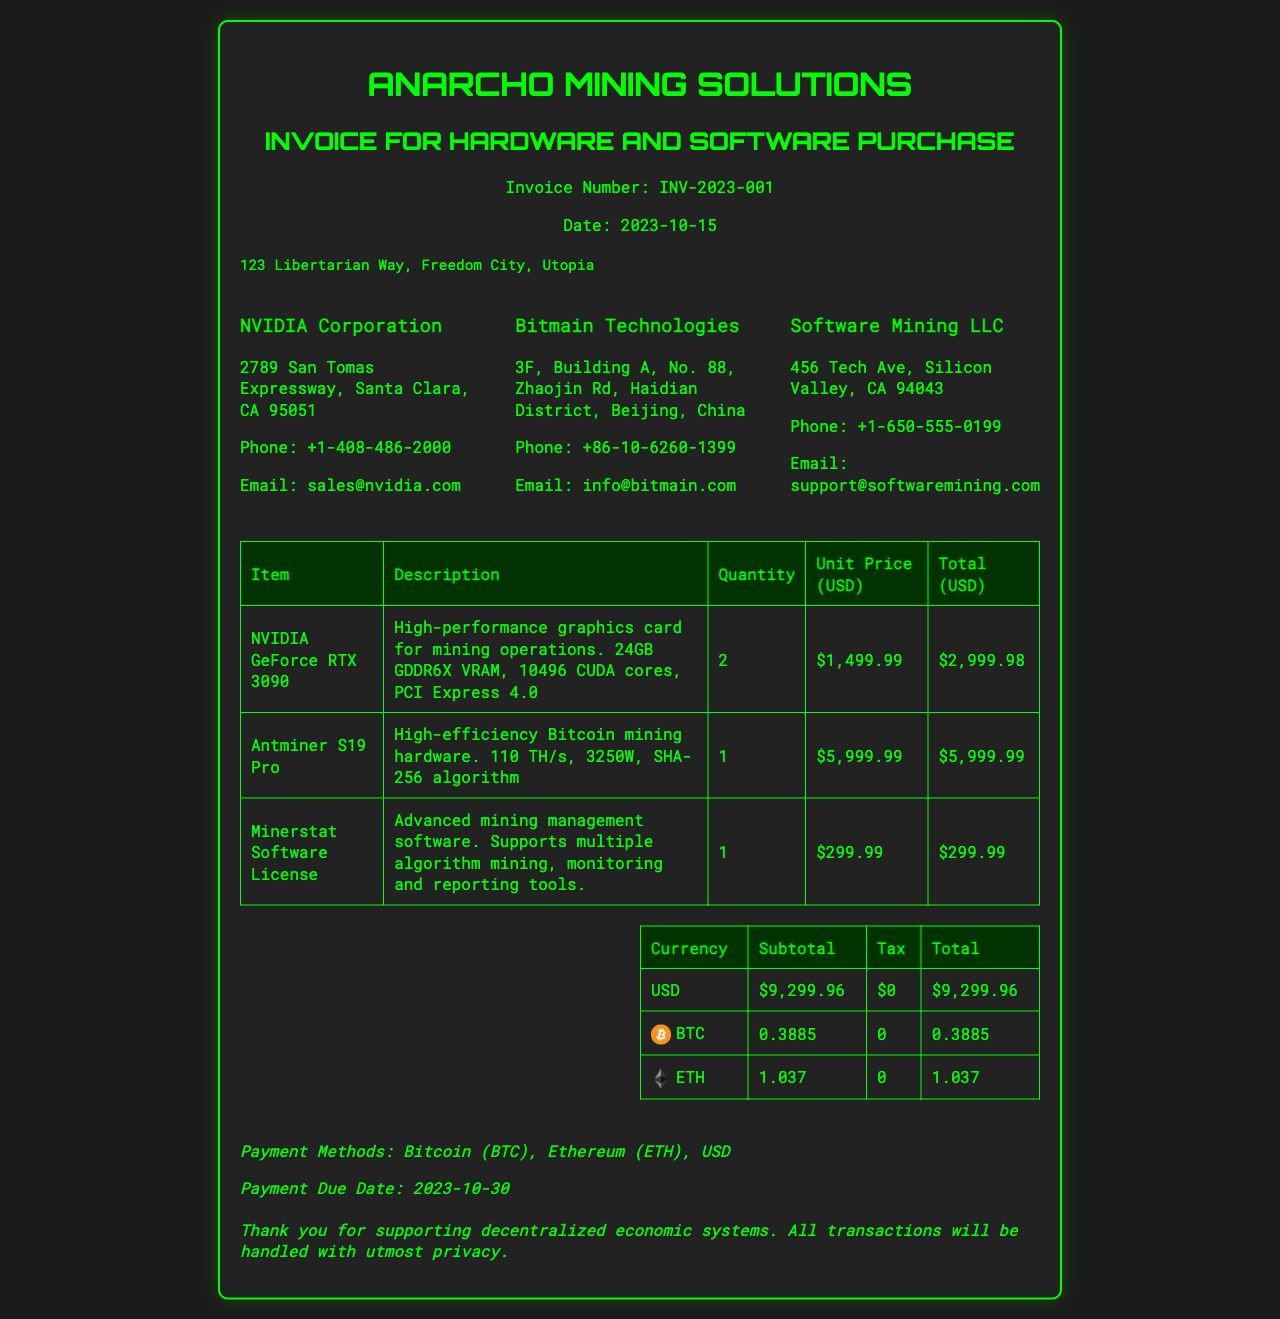what is the invoice number? The invoice number is uniquely assigned to this document for identification, which is INV-2023-001.
Answer: INV-2023-001 what is the date of the invoice? The date when this invoice was issued is important for payment timing and record keeping, which is 2023-10-15.
Answer: 2023-10-15 how many NVIDIA GeForce RTX 3090 graphics cards were purchased? The quantity specified for the NVIDIA GeForce RTX 3090 indicates how many were bought, which is 2.
Answer: 2 what is the total amount due in USD? The total amount due is the final cost of all items listed in the invoice, which sums up to $9,299.96.
Answer: $9,299.96 who is the vendor for the Antminer S19 Pro? The vendor information elaborates on the source of this product, which is Bitmain Technologies.
Answer: Bitmain Technologies what is the unit price of the Minerstat Software License? The unit price reflects the cost of a single item and is noted as $299.99.
Answer: $299.99 what are the payment methods accepted? Payment methods listed provide options for settling the invoice, which include Bitcoin, Ethereum, and USD.
Answer: Bitcoin, Ethereum, USD how much is the total in Bitcoin? Total in Bitcoin represents the equivalent amount due when choosing this payment method, which is 0.3885 BTC.
Answer: 0.3885 when is the payment due date? The due date is a critical deadline for payment submission, which is stated as 2023-10-30.
Answer: 2023-10-30 